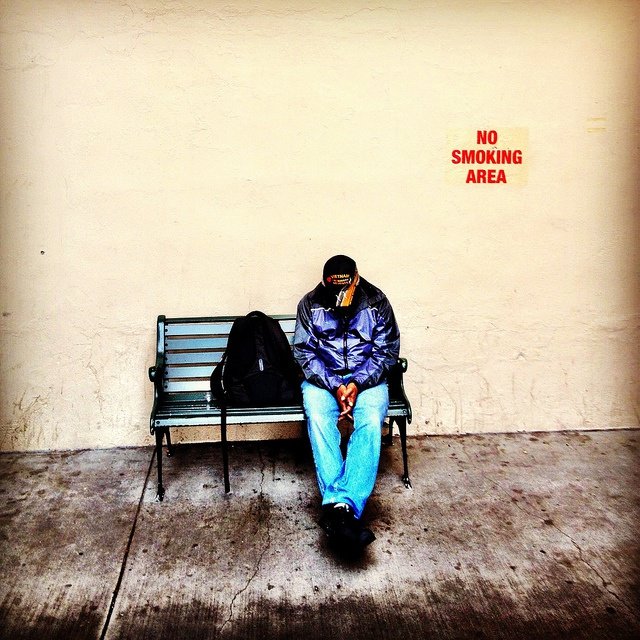Describe the objects in this image and their specific colors. I can see people in tan, black, cyan, white, and lightblue tones, bench in tan, black, lightblue, white, and gray tones, and backpack in tan, black, gray, lightgray, and darkgray tones in this image. 